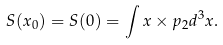Convert formula to latex. <formula><loc_0><loc_0><loc_500><loc_500>S ( x _ { 0 } ) = S ( 0 ) = \int x \times p _ { 2 } d ^ { 3 } x .</formula> 